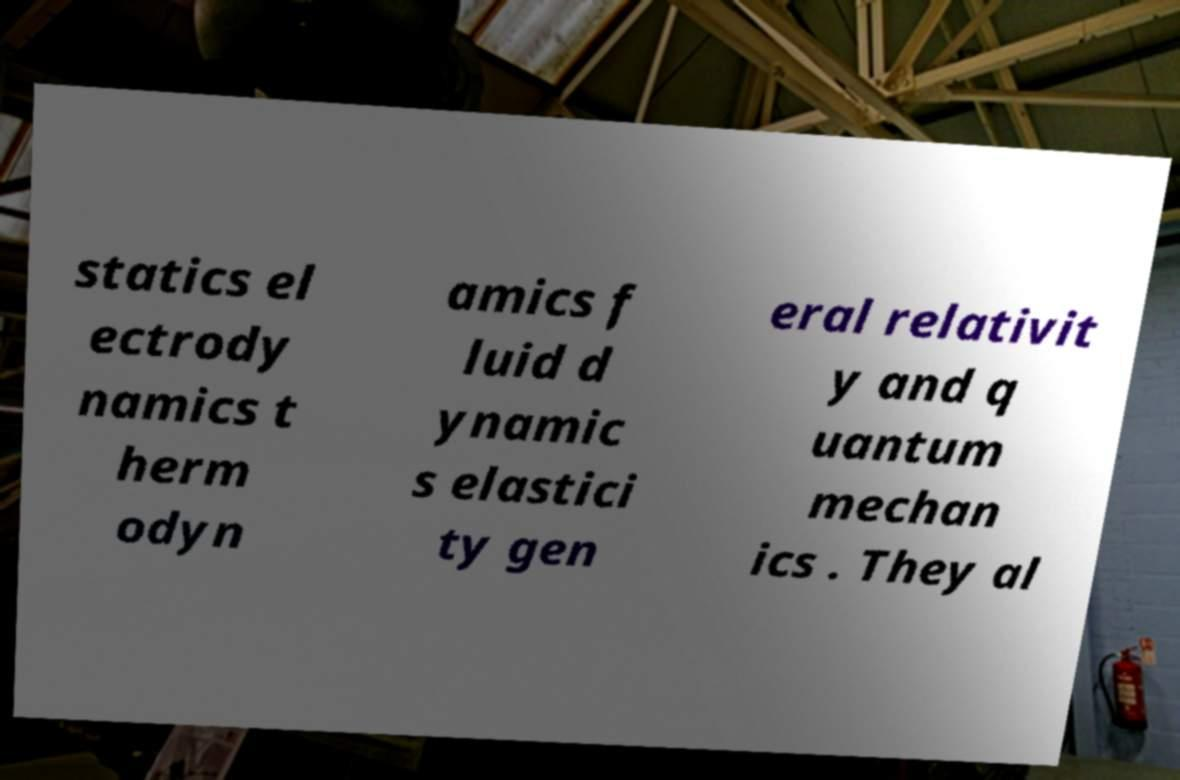For documentation purposes, I need the text within this image transcribed. Could you provide that? statics el ectrody namics t herm odyn amics f luid d ynamic s elastici ty gen eral relativit y and q uantum mechan ics . They al 